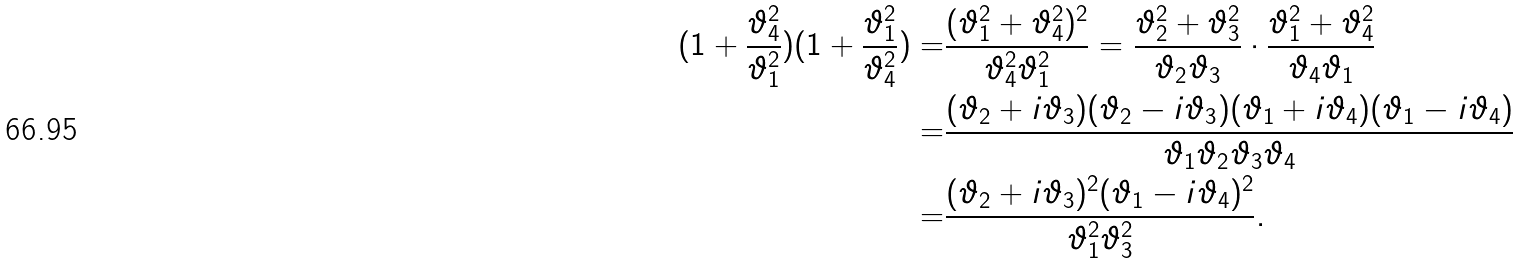<formula> <loc_0><loc_0><loc_500><loc_500>( 1 + \frac { \vartheta _ { 4 } ^ { 2 } } { \vartheta _ { 1 } ^ { 2 } } ) ( 1 + \frac { \vartheta _ { 1 } ^ { 2 } } { \vartheta _ { 4 } ^ { 2 } } ) = & \frac { ( \vartheta _ { 1 } ^ { 2 } + \vartheta _ { 4 } ^ { 2 } ) ^ { 2 } } { \vartheta _ { 4 } ^ { 2 } \vartheta _ { 1 } ^ { 2 } } = \frac { \vartheta _ { 2 } ^ { 2 } + \vartheta _ { 3 } ^ { 2 } } { \vartheta _ { 2 } \vartheta _ { 3 } } \cdot \frac { \vartheta _ { 1 } ^ { 2 } + \vartheta _ { 4 } ^ { 2 } } { \vartheta _ { 4 } \vartheta _ { 1 } } \\ = & \frac { ( \vartheta _ { 2 } + i \vartheta _ { 3 } ) ( \vartheta _ { 2 } - i \vartheta _ { 3 } ) ( \vartheta _ { 1 } + i \vartheta _ { 4 } ) ( \vartheta _ { 1 } - i \vartheta _ { 4 } ) } { \vartheta _ { 1 } \vartheta _ { 2 } \vartheta _ { 3 } \vartheta _ { 4 } } \\ = & \frac { ( \vartheta _ { 2 } + i \vartheta _ { 3 } ) ^ { 2 } ( \vartheta _ { 1 } - i \vartheta _ { 4 } ) ^ { 2 } } { \vartheta _ { 1 } ^ { 2 } \vartheta _ { 3 } ^ { 2 } } .</formula> 